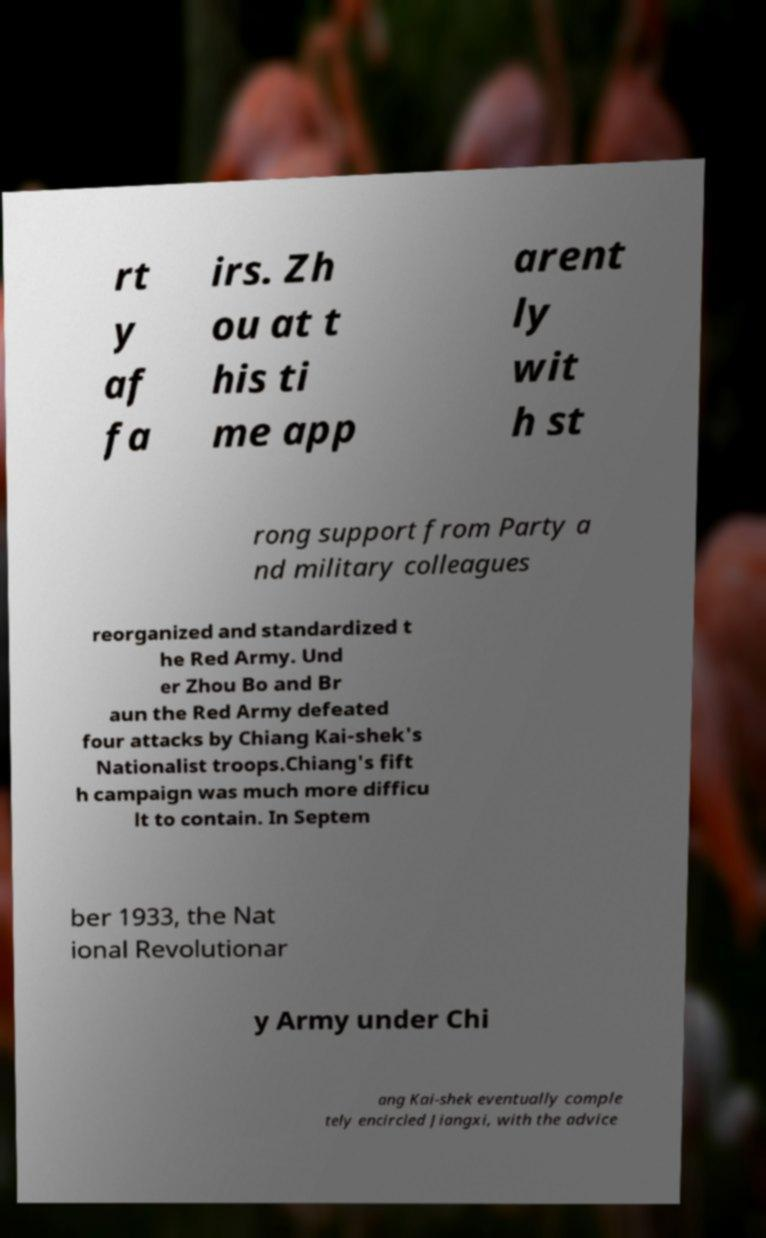Please read and relay the text visible in this image. What does it say? rt y af fa irs. Zh ou at t his ti me app arent ly wit h st rong support from Party a nd military colleagues reorganized and standardized t he Red Army. Und er Zhou Bo and Br aun the Red Army defeated four attacks by Chiang Kai-shek's Nationalist troops.Chiang's fift h campaign was much more difficu lt to contain. In Septem ber 1933, the Nat ional Revolutionar y Army under Chi ang Kai-shek eventually comple tely encircled Jiangxi, with the advice 